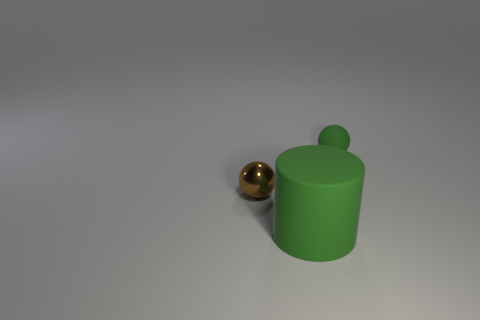What material is the tiny brown ball?
Your response must be concise. Metal. There is a tiny green object; how many small objects are to the left of it?
Make the answer very short. 1. Are the tiny sphere that is left of the cylinder and the cylinder made of the same material?
Your response must be concise. No. What number of other big rubber things have the same shape as the brown object?
Provide a short and direct response. 0. What number of small things are red things or green matte spheres?
Keep it short and to the point. 1. There is a thing right of the big cylinder; does it have the same color as the big thing?
Ensure brevity in your answer.  Yes. There is a object in front of the brown metallic object; is it the same color as the matte object that is behind the brown metal sphere?
Keep it short and to the point. Yes. Are there any tiny green balls that have the same material as the large thing?
Keep it short and to the point. Yes. What number of blue objects are either tiny objects or big rubber cylinders?
Offer a very short reply. 0. Are there more tiny balls on the right side of the brown shiny object than small blue metallic cubes?
Make the answer very short. Yes. 